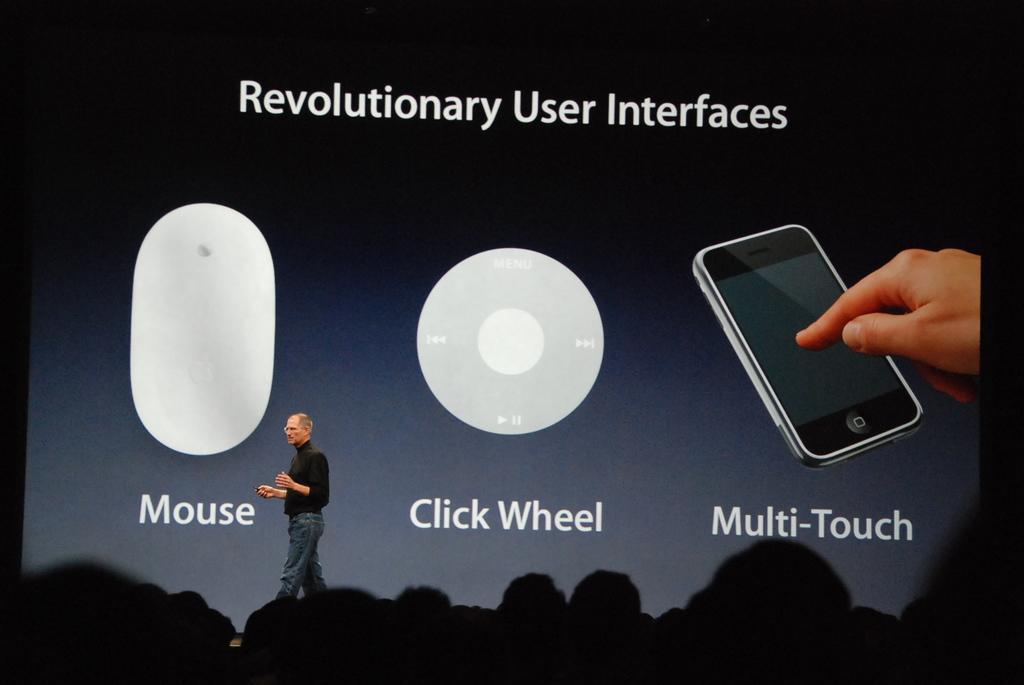Can you describe this image briefly? In the image I can see a person in black shirt is standing on the dais and behind there is a screen and also we can see some other people. 